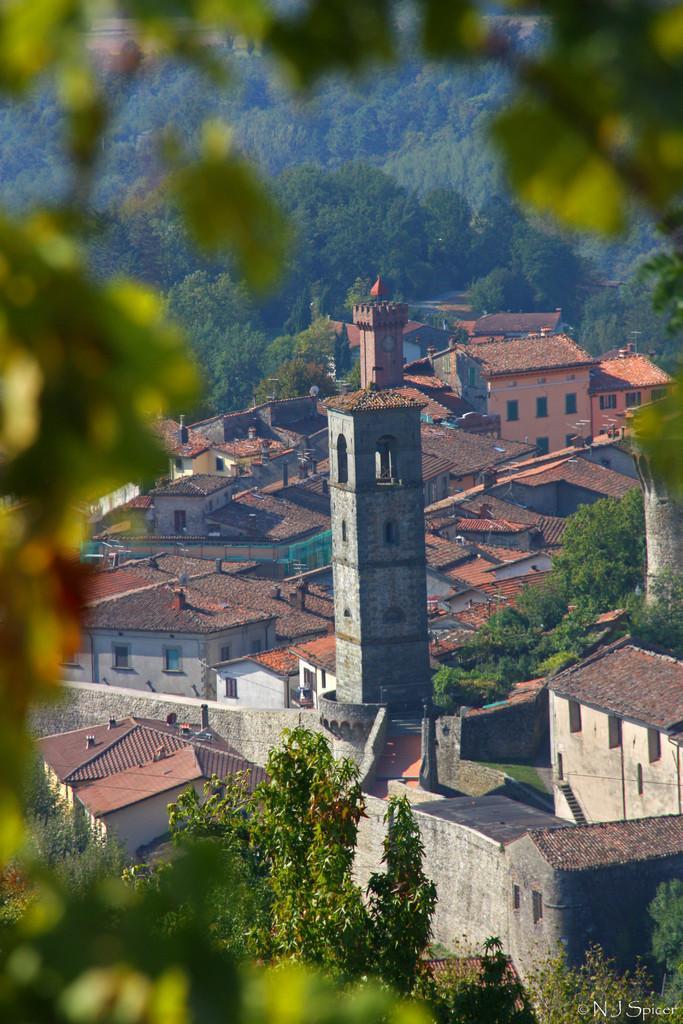Please provide a concise description of this image. In this image we can see few buildings and trees. 